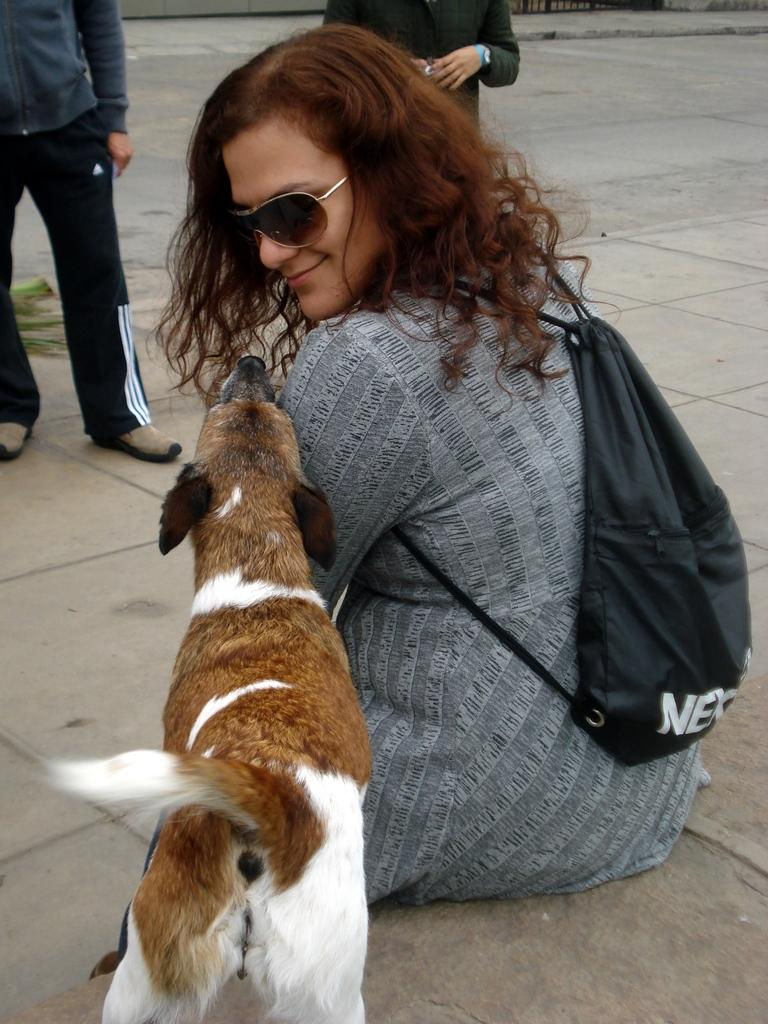What is in the foreground of the image? There is a dog and a woman wearing a bag in the foreground of the image. What is the woman sitting on? The woman is sitting on a stone surface. How many people are visible in the image? There are two people standing at the top of the image, in addition to the woman sitting. What can be seen in the background of the image? There is a road visible in the image. What type of kettle can be seen boiling water in the image? There is no kettle present in the image. What time does the watch in the image show? There is no watch present in the image. 